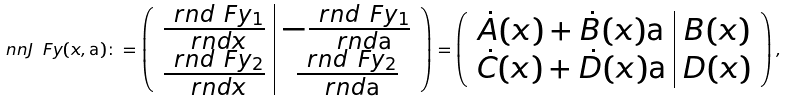Convert formula to latex. <formula><loc_0><loc_0><loc_500><loc_500>\ n n J \ F y ( x , \tt a ) \colon = \left ( \begin{array} { c | c } \frac { \ r n d \ F y _ { 1 } } { \ r n d x } & - \frac { \ r n d \ F y _ { 1 } } { \ r n d \tt a } \\ \frac { \ r n d \ F y _ { 2 } } { \ r n d x } & \frac { \ r n d \ F y _ { 2 } } { \ r n d \tt a } \end{array} \right ) = \left ( \begin{array} { c | c } \dot { A } ( x ) + \dot { B } ( x ) \tt a & B ( x ) \\ \dot { C } ( x ) + \dot { D } ( x ) \tt a & D ( x ) \end{array} \right ) ,</formula> 